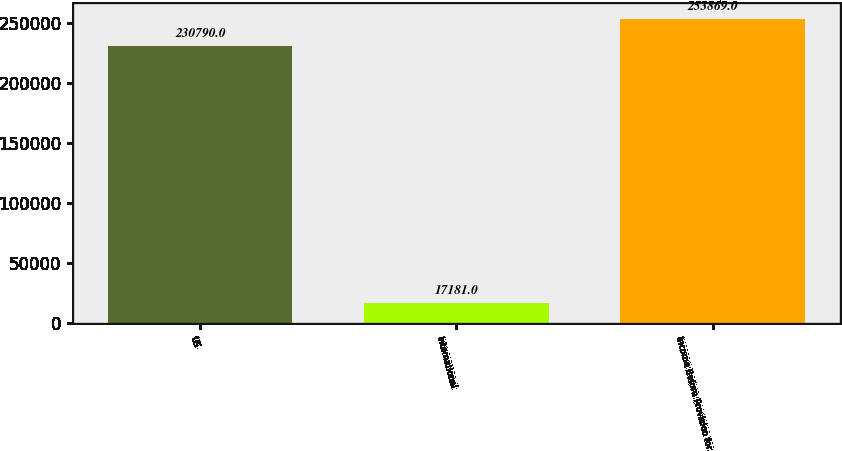Convert chart to OTSL. <chart><loc_0><loc_0><loc_500><loc_500><bar_chart><fcel>US<fcel>International<fcel>Income Before Provision for<nl><fcel>230790<fcel>17181<fcel>253869<nl></chart> 